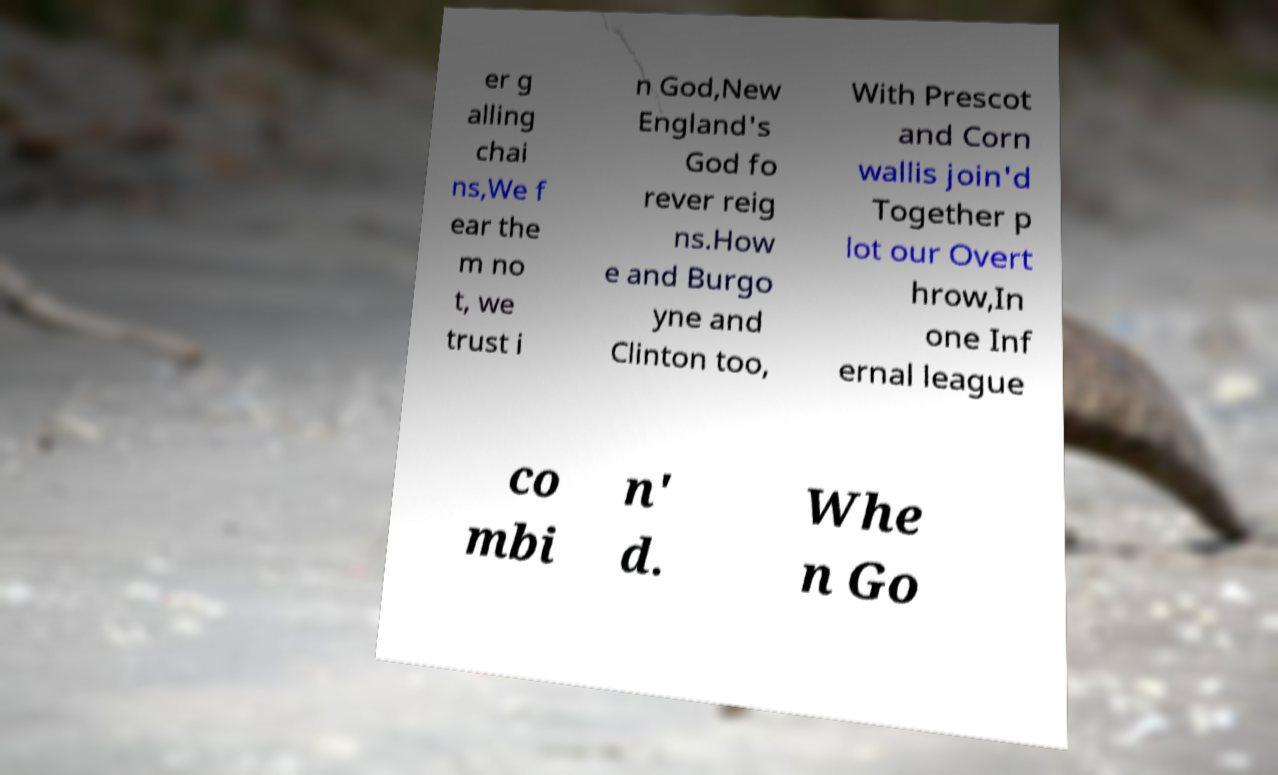I need the written content from this picture converted into text. Can you do that? er g alling chai ns,We f ear the m no t, we trust i n God,New England's God fo rever reig ns.How e and Burgo yne and Clinton too, With Prescot and Corn wallis join'd Together p lot our Overt hrow,In one Inf ernal league co mbi n' d. Whe n Go 